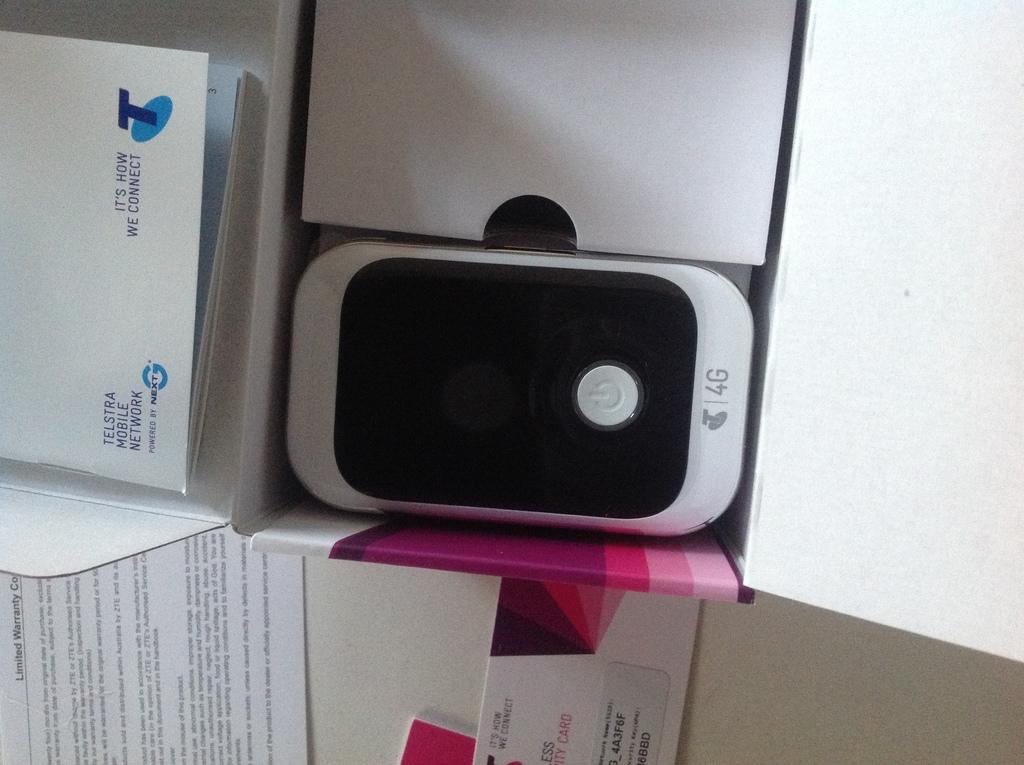<image>
Write a terse but informative summary of the picture. Telstra phone sitting in the middle of some boxes. 